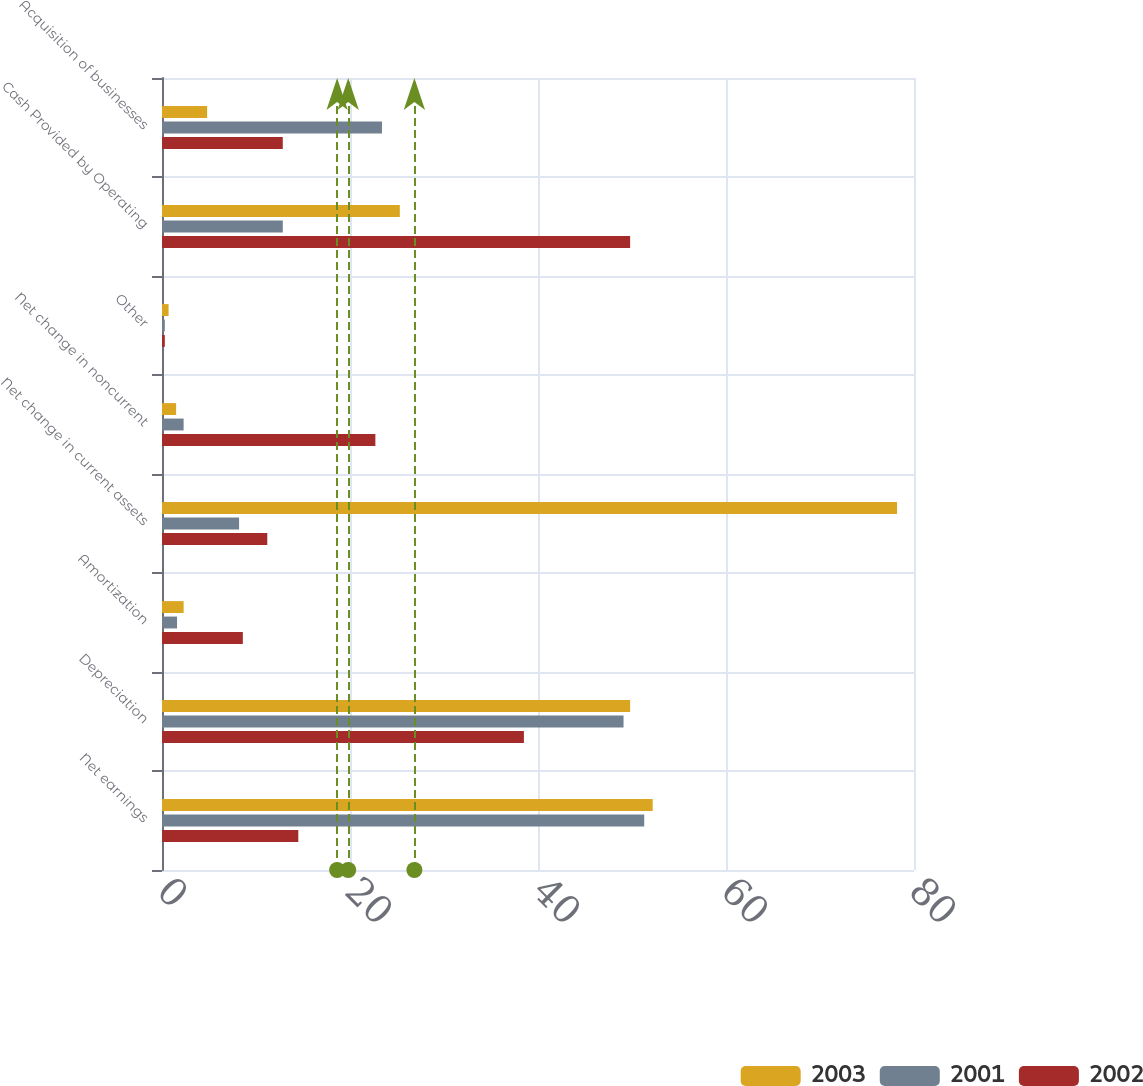Convert chart to OTSL. <chart><loc_0><loc_0><loc_500><loc_500><stacked_bar_chart><ecel><fcel>Net earnings<fcel>Depreciation<fcel>Amortization<fcel>Net change in current assets<fcel>Net change in noncurrent<fcel>Other<fcel>Cash Provided by Operating<fcel>Acquisition of businesses<nl><fcel>2003<fcel>52.2<fcel>49.8<fcel>2.3<fcel>78.2<fcel>1.5<fcel>0.7<fcel>25.3<fcel>4.8<nl><fcel>2001<fcel>51.3<fcel>49.1<fcel>1.6<fcel>8.2<fcel>2.3<fcel>0.3<fcel>12.85<fcel>23.4<nl><fcel>2002<fcel>14.5<fcel>38.5<fcel>8.6<fcel>11.2<fcel>22.7<fcel>0.3<fcel>49.8<fcel>12.85<nl></chart> 